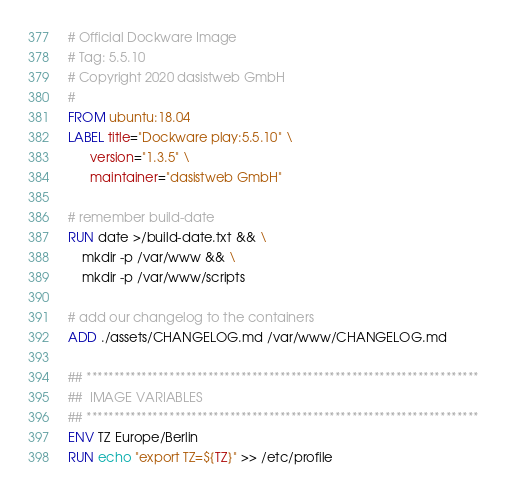<code> <loc_0><loc_0><loc_500><loc_500><_Dockerfile_># Official Dockware Image
# Tag: 5.5.10
# Copyright 2020 dasistweb GmbH
#
FROM ubuntu:18.04
LABEL title="Dockware play:5.5.10" \
      version="1.3.5" \
      maintainer="dasistweb GmbH"

# remember build-date
RUN date >/build-date.txt && \
    mkdir -p /var/www && \
    mkdir -p /var/www/scripts

# add our changelog to the containers
ADD ./assets/CHANGELOG.md /var/www/CHANGELOG.md

## ***********************************************************************
##  IMAGE VARIABLES
## ***********************************************************************
ENV TZ Europe/Berlin
RUN echo "export TZ=${TZ}" >> /etc/profile
</code> 